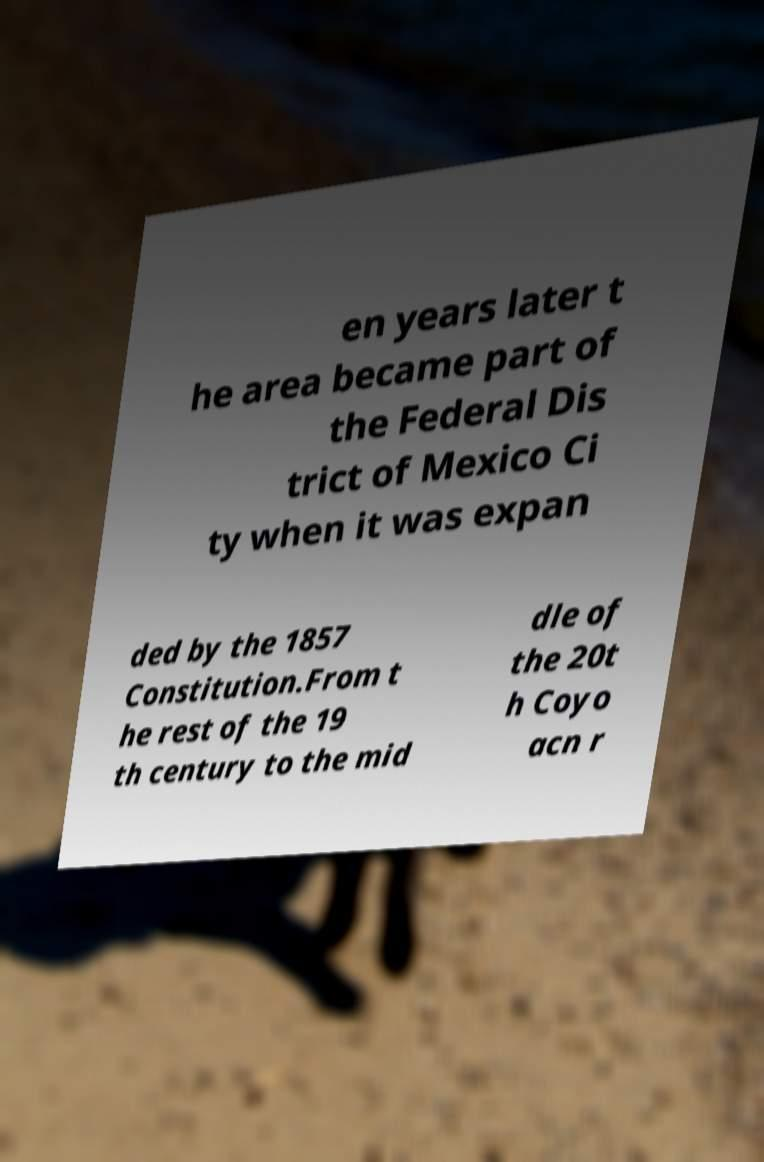Could you extract and type out the text from this image? en years later t he area became part of the Federal Dis trict of Mexico Ci ty when it was expan ded by the 1857 Constitution.From t he rest of the 19 th century to the mid dle of the 20t h Coyo acn r 